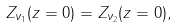<formula> <loc_0><loc_0><loc_500><loc_500>Z _ { \nu _ { 1 } } ( z = 0 ) = Z _ { \nu _ { 2 } } ( z = 0 ) ,</formula> 